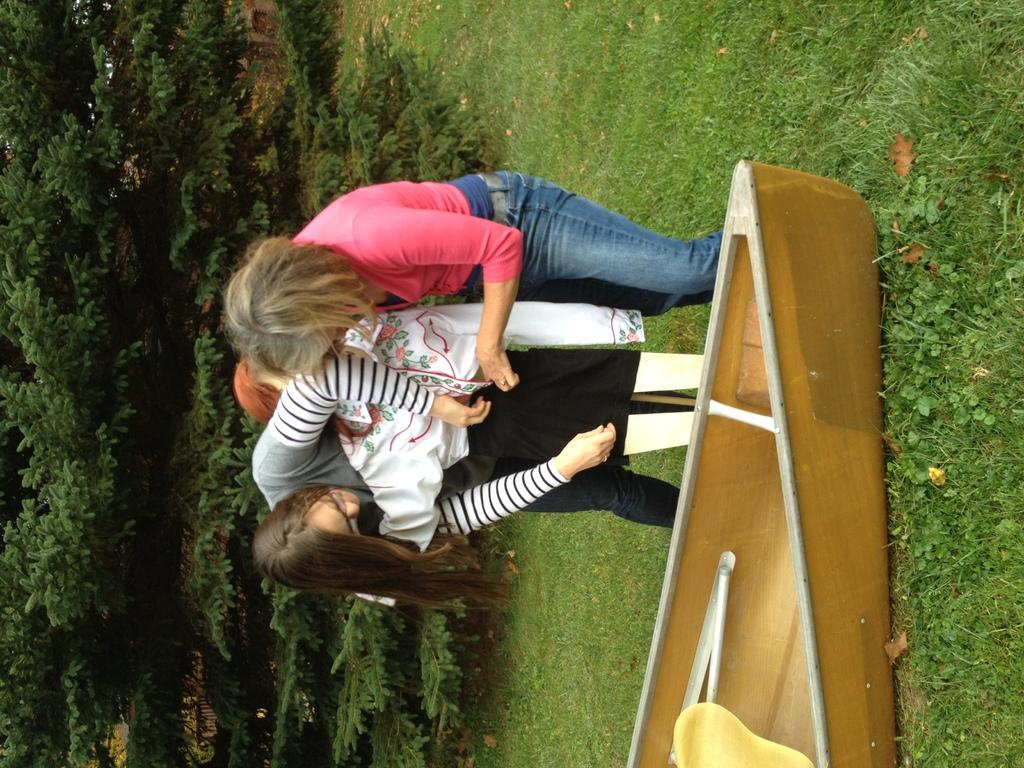Who or what is present in the image? There are people in the image. What is the unusual object on the grass in the image? There is a boat on the grass in the image. How is the boat positioned in the image? The boat appears to be truncated. What type of vegetation is on the left side of the image? There are plants on the left side of the image. What type of toothpaste is being used by the people in the image? There is no toothpaste present in the image. Can you see any police officers in the image? There is no mention of police officers in the image. 